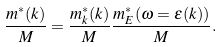<formula> <loc_0><loc_0><loc_500><loc_500>\frac { m ^ { \ast } ( k ) } { M } = \frac { m ^ { \ast } _ { k } ( k ) } { M } \frac { m ^ { \ast } _ { E } ( \omega = \varepsilon ( k ) ) } { M } .</formula> 